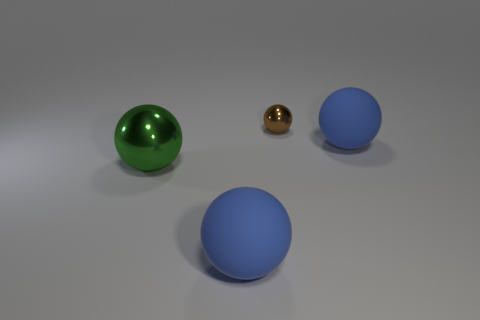Is there any indication of the material the spheres are made of? The green and blue spheres have a diffuse, matte finish indicative of a non-metallic material. In contrast, the small gold sphere has a shiny, reflective surface that suggests it is made of metal, possibly brass or gold. How does the lighting in the image affect the appearance of the spheres? The lighting in the image highlights the texture and color of the spheres. It creates a soft shadow on the ground, emphasizing the three-dimensionality of the objects, and the reflective qualities of the gold sphere are accentuated by the bright spots of light reflecting off its surface. 